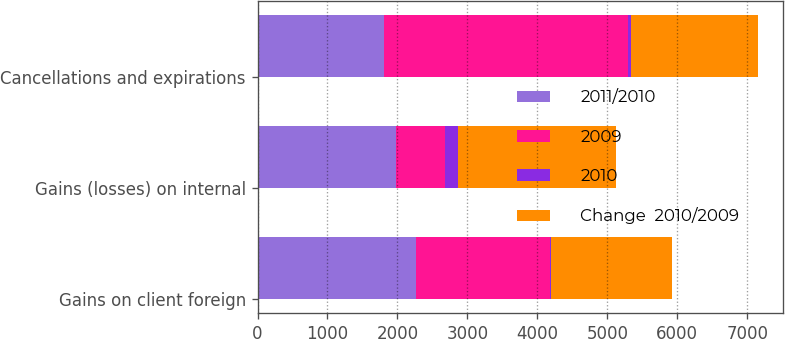Convert chart. <chart><loc_0><loc_0><loc_500><loc_500><stacked_bar_chart><ecel><fcel>Gains on client foreign<fcel>Gains (losses) on internal<fcel>Cancellations and expirations<nl><fcel>2011/2010<fcel>2259<fcel>1973<fcel>1806<nl><fcel>2009<fcel>1914<fcel>710<fcel>3488<nl><fcel>2010<fcel>18<fcel>177.9<fcel>48.2<nl><fcel>Change  2010/2009<fcel>1730<fcel>2258<fcel>1806<nl></chart> 